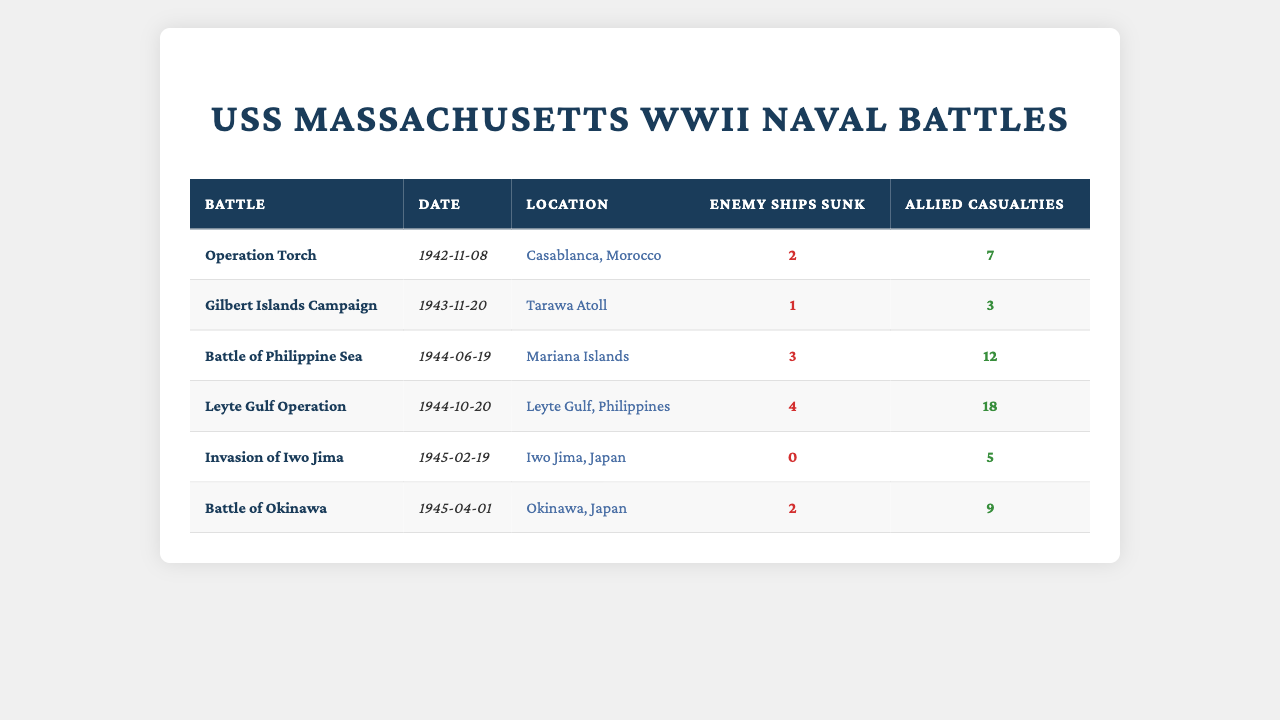What was the location of the Battle of Okinawa? The table lists the location of each battle, and for the Battle of Okinawa, it shows "Okinawa, Japan" in the location column.
Answer: Okinawa, Japan How many enemy ships were sunk during the Leyte Gulf Operation? The table indicates that during the Leyte Gulf Operation, the number of enemy ships sunk is listed as 4 in the respective column.
Answer: 4 What is the total number of enemy ships sunk across all battles? To find the total, we sum the enemy ships sunk in each battle: 2 (Operation Torch) + 1 (Gilbert Islands Campaign) + 3 (Battle of Philippine Sea) + 4 (Leyte Gulf Operation) + 0 (Invasion of Iwo Jima) + 2 (Battle of Okinawa) = 12.
Answer: 12 Did any battle result in zero enemy ships sunk? By reviewing the table, the Invasion of Iwo Jima shows that 0 enemy ships were sunk, indicating that at least one battle did not result in any enemy ships being sunk.
Answer: Yes Which battle had the highest number of Allied casualties? Observing the Allied casualties, the Leyte Gulf Operation shows the highest number at 18, which is greater than the casualties in other battles listed in the table.
Answer: Leyte Gulf Operation What was the average number of enemy ships sunk per battle? To find the average, we first determine the total number of enemy ships sunk, which is 12, and since there are 6 battles, we divide 12 by 6. Thus, the average is 12/6 = 2.
Answer: 2 How many Allied casualties were reported in the Gilbert Islands Campaign and the Battle of Okinawa combined? Looking at the table, the Gilbert Islands Campaign had 3 Allied casualties, and the Battle of Okinawa had 9. Adding them together gives us 3 + 9 = 12 combined Allied casualties.
Answer: 12 What date was the Battle of Philippine Sea fought? The table shows the date for the Battle of Philippine Sea listed as June 19, 1944, in the respective column.
Answer: June 19, 1944 Which battle took place first: Operation Torch or the Leyte Gulf Operation? From the date column, Operation Torch is on November 8, 1942, and the Leyte Gulf Operation is on October 20, 1944. Since November 8, 1942, is earlier than October 20, 1944, Operation Torch took place first.
Answer: Operation Torch How many more Allied casualties were there in the Battle of Okinawa compared to the Invasion of Iwo Jima? The Battle of Okinawa had 9 Allied casualties, and the Invasion of Iwo Jima had 5. The difference is 9 - 5 = 4, indicating there were 4 more casualties in the Battle of Okinawa.
Answer: 4 